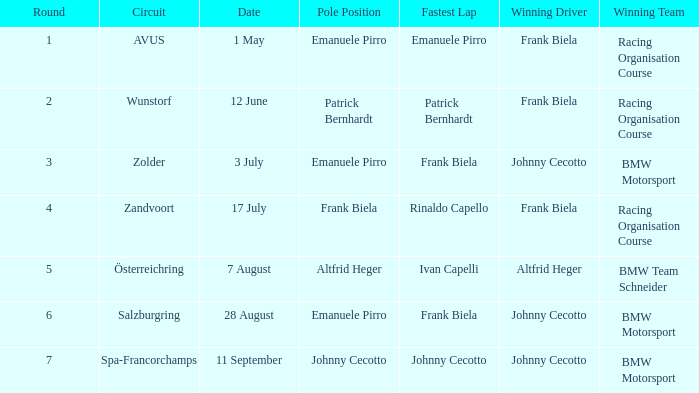Give me the full table as a dictionary. {'header': ['Round', 'Circuit', 'Date', 'Pole Position', 'Fastest Lap', 'Winning Driver', 'Winning Team'], 'rows': [['1', 'AVUS', '1 May', 'Emanuele Pirro', 'Emanuele Pirro', 'Frank Biela', 'Racing Organisation Course'], ['2', 'Wunstorf', '12 June', 'Patrick Bernhardt', 'Patrick Bernhardt', 'Frank Biela', 'Racing Organisation Course'], ['3', 'Zolder', '3 July', 'Emanuele Pirro', 'Frank Biela', 'Johnny Cecotto', 'BMW Motorsport'], ['4', 'Zandvoort', '17 July', 'Frank Biela', 'Rinaldo Capello', 'Frank Biela', 'Racing Organisation Course'], ['5', 'Österreichring', '7 August', 'Altfrid Heger', 'Ivan Capelli', 'Altfrid Heger', 'BMW Team Schneider'], ['6', 'Salzburgring', '28 August', 'Emanuele Pirro', 'Frank Biela', 'Johnny Cecotto', 'BMW Motorsport'], ['7', 'Spa-Francorchamps', '11 September', 'Johnny Cecotto', 'Johnny Cecotto', 'Johnny Cecotto', 'BMW Motorsport']]} Who was the winning team on the circuit Zolder? BMW Motorsport. 